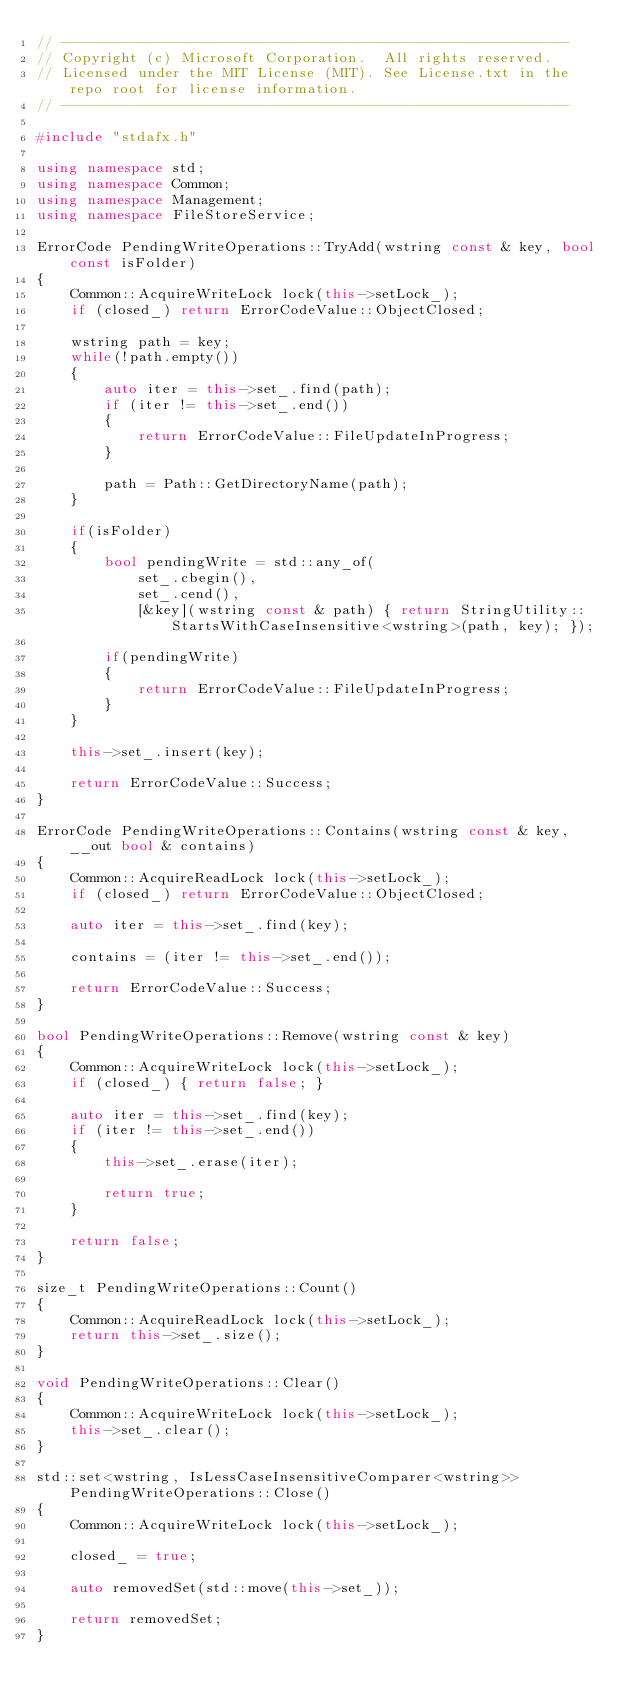<code> <loc_0><loc_0><loc_500><loc_500><_C++_>// ------------------------------------------------------------
// Copyright (c) Microsoft Corporation.  All rights reserved.
// Licensed under the MIT License (MIT). See License.txt in the repo root for license information.
// ------------------------------------------------------------

#include "stdafx.h"

using namespace std;
using namespace Common;
using namespace Management;
using namespace FileStoreService;

ErrorCode PendingWriteOperations::TryAdd(wstring const & key, bool const isFolder)
{
    Common::AcquireWriteLock lock(this->setLock_);
    if (closed_) return ErrorCodeValue::ObjectClosed;
    
    wstring path = key;
    while(!path.empty())
    {
        auto iter = this->set_.find(path);
        if (iter != this->set_.end())
        {
            return ErrorCodeValue::FileUpdateInProgress;
        }

        path = Path::GetDirectoryName(path);
    }

    if(isFolder)
    {
        bool pendingWrite = std::any_of(
            set_.cbegin(),
            set_.cend(),
            [&key](wstring const & path) { return StringUtility::StartsWithCaseInsensitive<wstring>(path, key); });

        if(pendingWrite)
        {
            return ErrorCodeValue::FileUpdateInProgress;
        }
    }

    this->set_.insert(key);

    return ErrorCodeValue::Success;
}

ErrorCode PendingWriteOperations::Contains(wstring const & key, __out bool & contains)
{
    Common::AcquireReadLock lock(this->setLock_);
    if (closed_) return ErrorCodeValue::ObjectClosed;

    auto iter = this->set_.find(key);

    contains = (iter != this->set_.end());

    return ErrorCodeValue::Success;
}

bool PendingWriteOperations::Remove(wstring const & key)
{
    Common::AcquireWriteLock lock(this->setLock_);
    if (closed_) { return false; }

    auto iter = this->set_.find(key);
    if (iter != this->set_.end())
    {
        this->set_.erase(iter);

        return true;
    }

    return false;
}

size_t PendingWriteOperations::Count()
{
    Common::AcquireReadLock lock(this->setLock_);
    return this->set_.size();
}

void PendingWriteOperations::Clear()
{
    Common::AcquireWriteLock lock(this->setLock_);
    this->set_.clear();
}

std::set<wstring, IsLessCaseInsensitiveComparer<wstring>> PendingWriteOperations::Close()
{
    Common::AcquireWriteLock lock(this->setLock_);

    closed_ = true;

    auto removedSet(std::move(this->set_));

    return removedSet;
}
</code> 